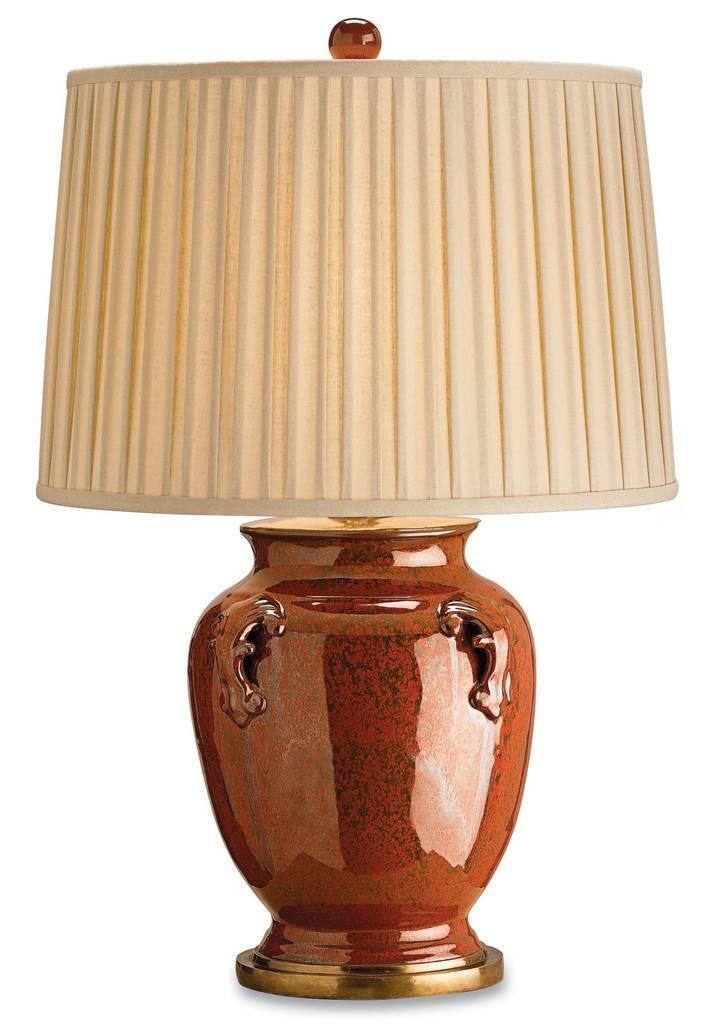In one or two sentences, can you explain what this image depicts? In this image, I can see a lamp. This is the lamp base, which is brown in color. I can see a lamp shade, which is attached to the lamp base. The background looks white in color. 